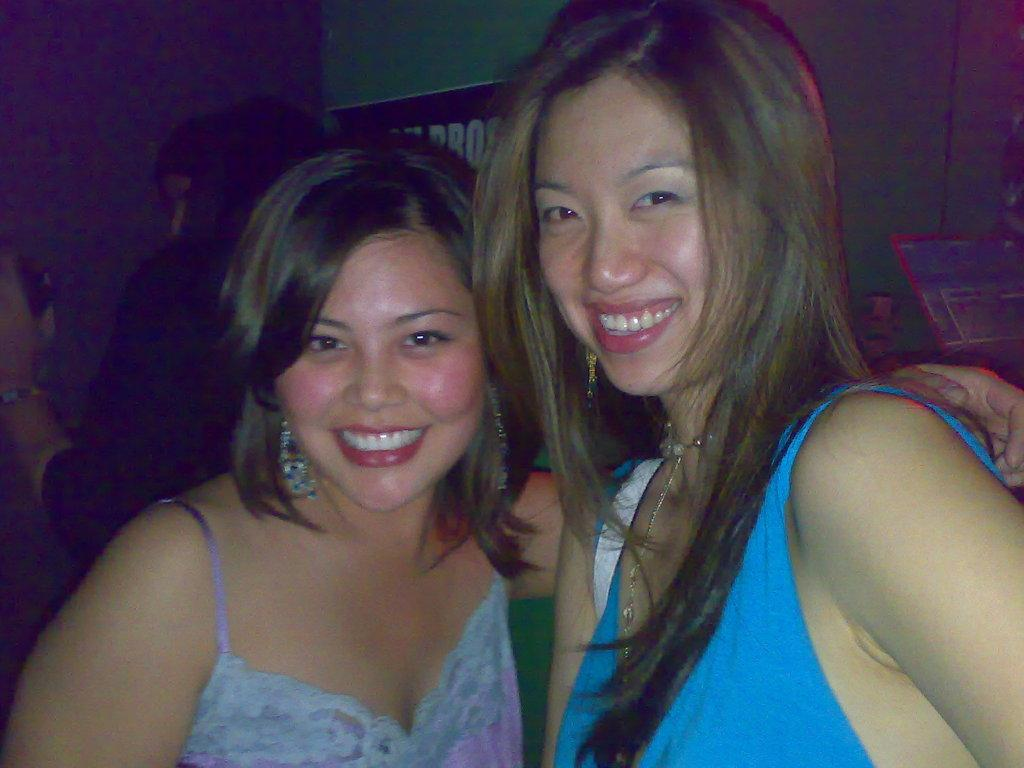How many women are in the image? There are two women in the image. What expression do the women have? The women are smiling. What can be seen in the background of the image? There are people, a wall, and a poster in the background of the image. Can you describe the object on the right side of the image? Unfortunately, the provided facts do not give enough information to describe the object on the right side of the image. What type of nut is being used as a toy by the women in the image? There is no nut or toy present in the image; the women are simply smiling. 